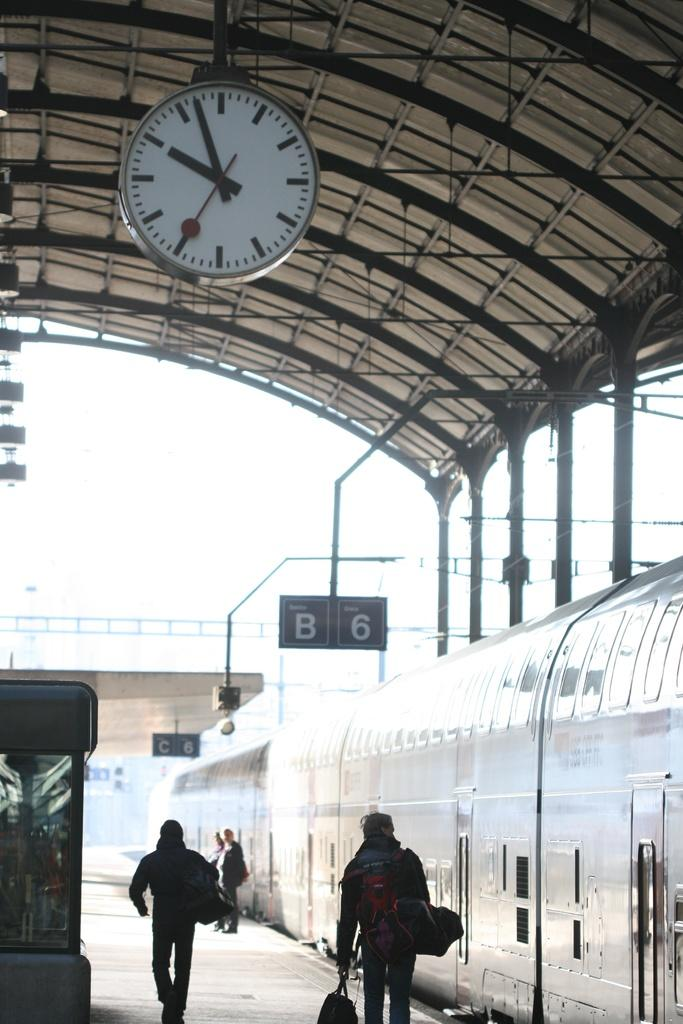<image>
Render a clear and concise summary of the photo. A train is pulled up alongside signs designating B6. 